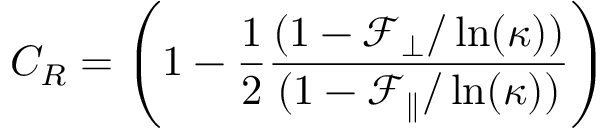<formula> <loc_0><loc_0><loc_500><loc_500>C _ { R } = \left ( 1 - \frac { 1 } { 2 } \frac { ( 1 - \mathcal { F } _ { \perp } / \ln ( \kappa ) ) } { ( 1 - \mathcal { F } _ { \| } / \ln ( \kappa ) ) } \right )</formula> 